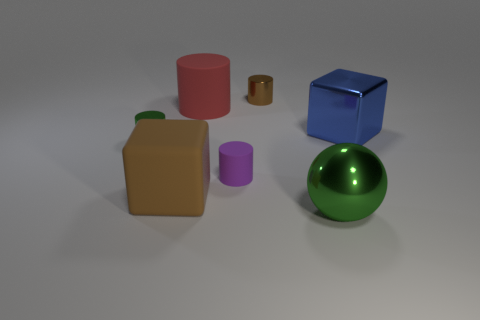Do the brown shiny cylinder and the green shiny object on the right side of the small brown object have the same size?
Keep it short and to the point. No. There is a large rubber object that is behind the purple matte thing; what color is it?
Your answer should be compact. Red. What is the shape of the small metal object that is the same color as the metal sphere?
Provide a short and direct response. Cylinder. What shape is the large red thing behind the sphere?
Your response must be concise. Cylinder. How many yellow things are blocks or big things?
Make the answer very short. 0. Is the material of the tiny purple thing the same as the tiny brown cylinder?
Your answer should be very brief. No. There is a tiny matte cylinder; what number of metallic blocks are behind it?
Provide a short and direct response. 1. There is a object that is both in front of the small green metallic cylinder and left of the big red cylinder; what material is it?
Your answer should be very brief. Rubber. What number of spheres are either tiny rubber objects or tiny green objects?
Keep it short and to the point. 0. There is another object that is the same shape as the big blue metallic object; what is its material?
Offer a very short reply. Rubber. 